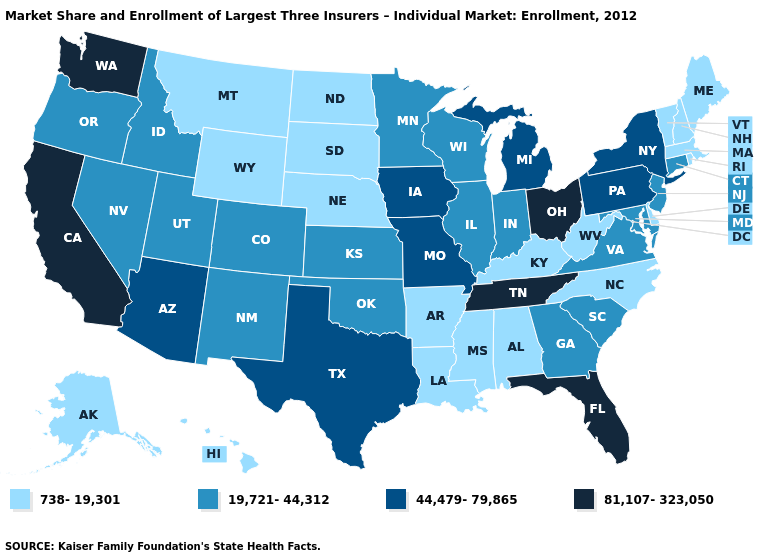What is the highest value in states that border New Jersey?
Give a very brief answer. 44,479-79,865. What is the value of North Carolina?
Short answer required. 738-19,301. Which states hav the highest value in the South?
Concise answer only. Florida, Tennessee. Which states have the lowest value in the USA?
Write a very short answer. Alabama, Alaska, Arkansas, Delaware, Hawaii, Kentucky, Louisiana, Maine, Massachusetts, Mississippi, Montana, Nebraska, New Hampshire, North Carolina, North Dakota, Rhode Island, South Dakota, Vermont, West Virginia, Wyoming. What is the highest value in the MidWest ?
Concise answer only. 81,107-323,050. What is the lowest value in the USA?
Give a very brief answer. 738-19,301. Does Washington have a higher value than Alaska?
Write a very short answer. Yes. Among the states that border Arizona , does California have the lowest value?
Concise answer only. No. Does Georgia have a higher value than New Hampshire?
Keep it brief. Yes. Does Ohio have the highest value in the MidWest?
Quick response, please. Yes. Among the states that border Wyoming , which have the lowest value?
Be succinct. Montana, Nebraska, South Dakota. Which states hav the highest value in the South?
Write a very short answer. Florida, Tennessee. Does West Virginia have the same value as Ohio?
Concise answer only. No. Which states have the lowest value in the USA?
Be succinct. Alabama, Alaska, Arkansas, Delaware, Hawaii, Kentucky, Louisiana, Maine, Massachusetts, Mississippi, Montana, Nebraska, New Hampshire, North Carolina, North Dakota, Rhode Island, South Dakota, Vermont, West Virginia, Wyoming. What is the value of Arizona?
Write a very short answer. 44,479-79,865. 